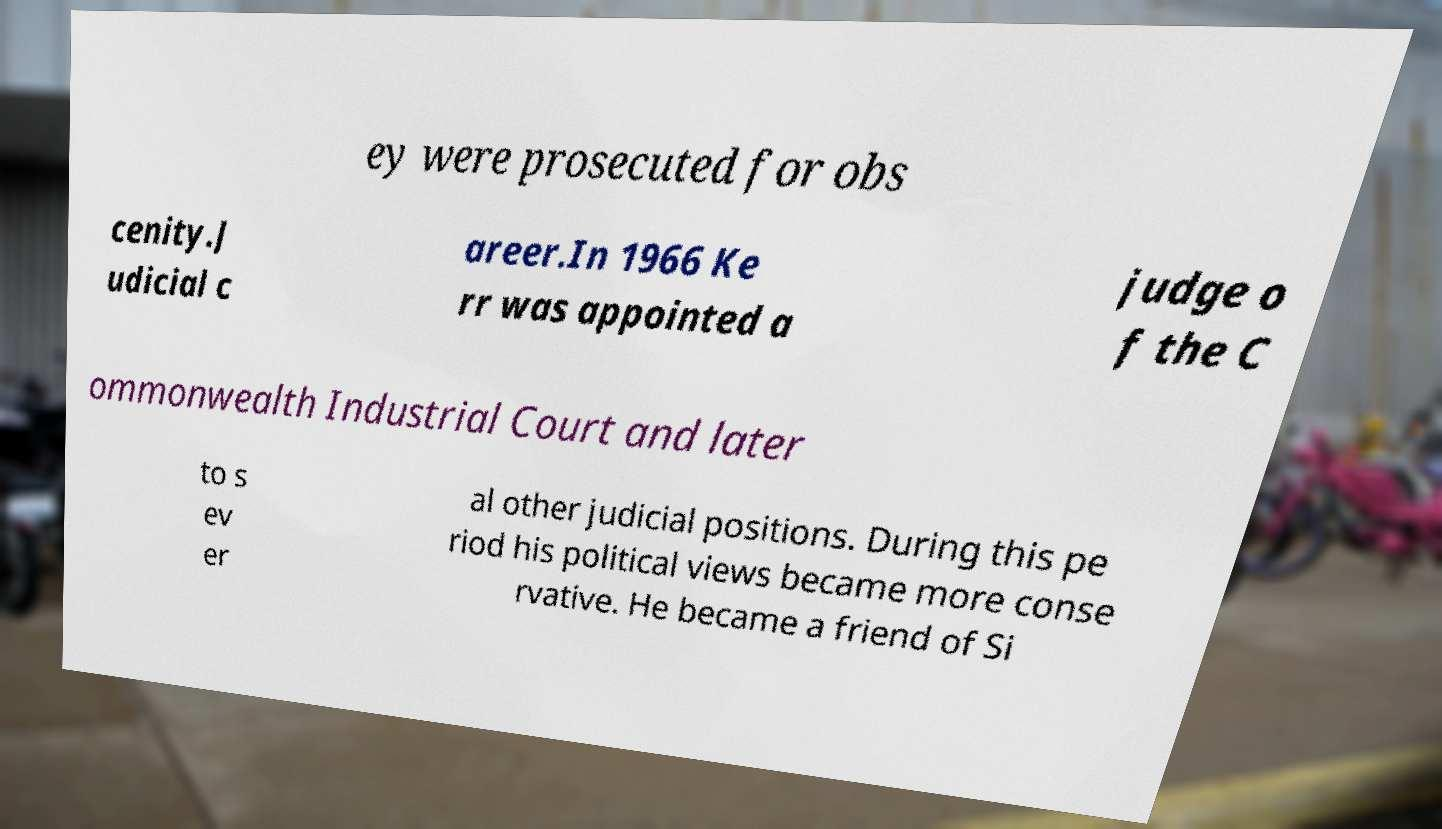There's text embedded in this image that I need extracted. Can you transcribe it verbatim? ey were prosecuted for obs cenity.J udicial c areer.In 1966 Ke rr was appointed a judge o f the C ommonwealth Industrial Court and later to s ev er al other judicial positions. During this pe riod his political views became more conse rvative. He became a friend of Si 